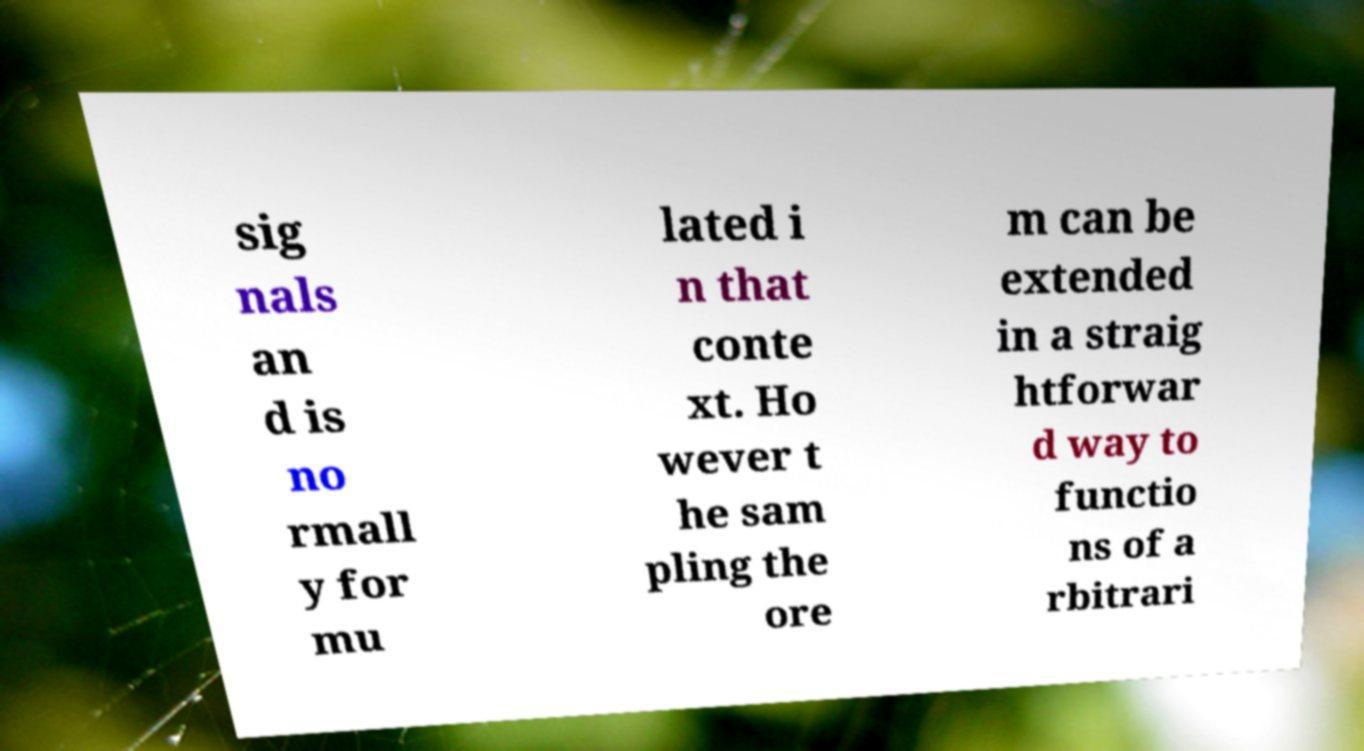There's text embedded in this image that I need extracted. Can you transcribe it verbatim? sig nals an d is no rmall y for mu lated i n that conte xt. Ho wever t he sam pling the ore m can be extended in a straig htforwar d way to functio ns of a rbitrari 